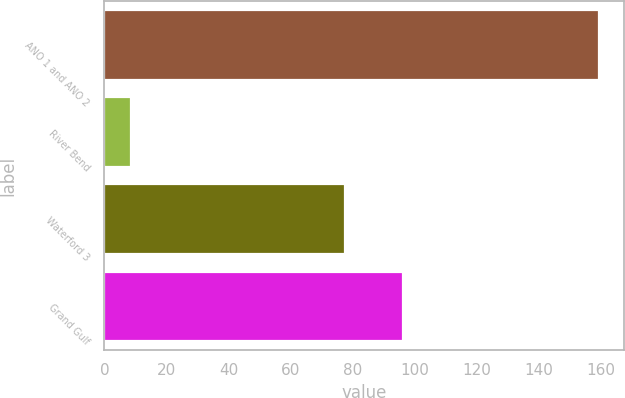Convert chart to OTSL. <chart><loc_0><loc_0><loc_500><loc_500><bar_chart><fcel>ANO 1 and ANO 2<fcel>River Bend<fcel>Waterford 3<fcel>Grand Gulf<nl><fcel>159.5<fcel>8.7<fcel>77.7<fcel>96.1<nl></chart> 